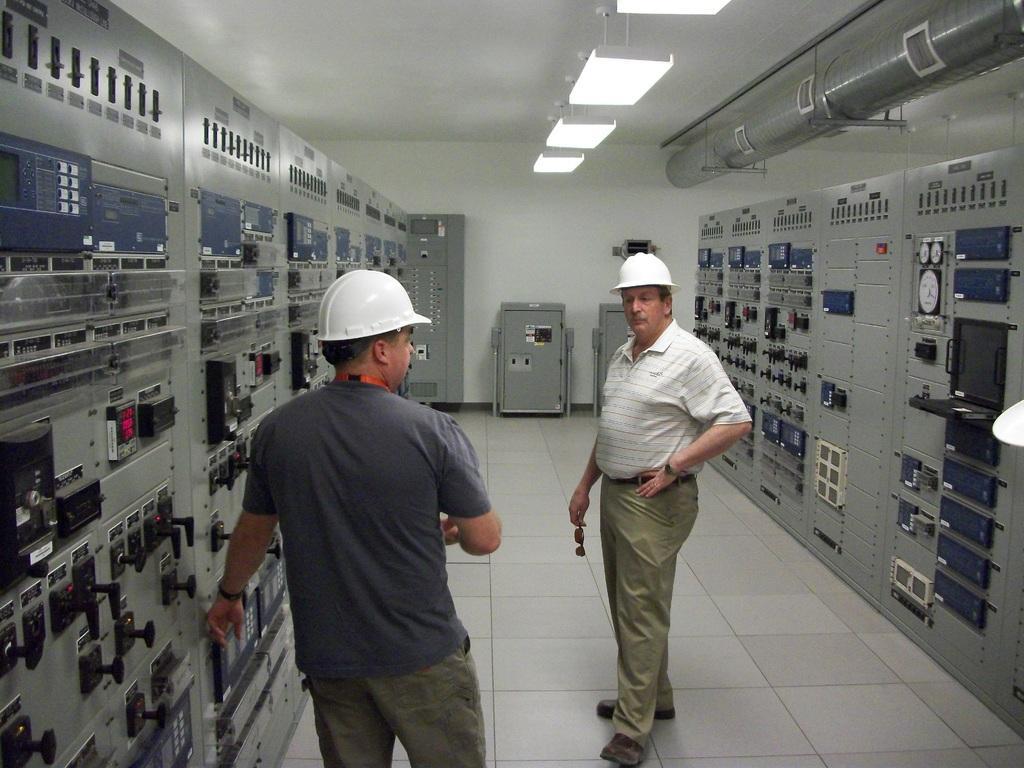Please provide a concise description of this image. At the top we can see the ceiling, lights and the objects In this picture we can see the men wearing helmets and standing on the floor. On the right and left side of the picture we can see the machines. In the background we can see the wall and the objects. 